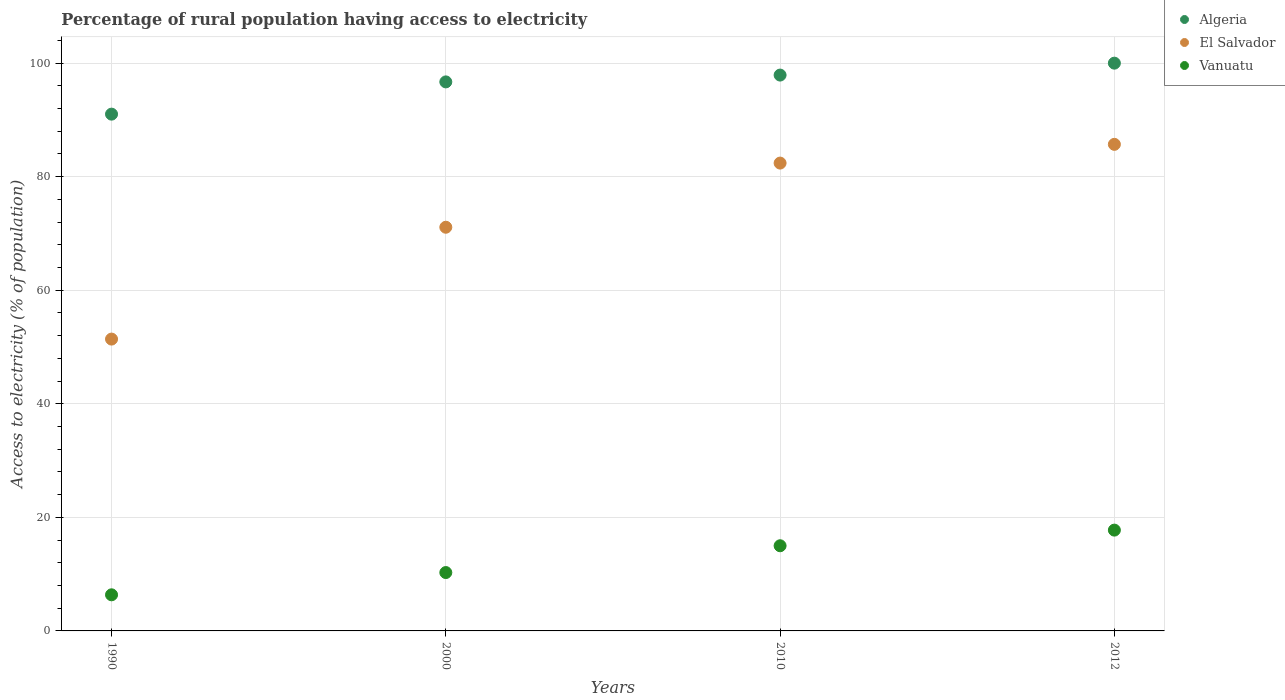How many different coloured dotlines are there?
Offer a terse response. 3. Is the number of dotlines equal to the number of legend labels?
Offer a terse response. Yes. What is the percentage of rural population having access to electricity in Vanuatu in 1990?
Your answer should be very brief. 6.36. Across all years, what is the maximum percentage of rural population having access to electricity in Vanuatu?
Provide a succinct answer. 17.75. Across all years, what is the minimum percentage of rural population having access to electricity in El Salvador?
Your response must be concise. 51.4. What is the total percentage of rural population having access to electricity in El Salvador in the graph?
Your response must be concise. 290.6. What is the difference between the percentage of rural population having access to electricity in El Salvador in 1990 and that in 2012?
Your response must be concise. -34.3. What is the difference between the percentage of rural population having access to electricity in El Salvador in 2000 and the percentage of rural population having access to electricity in Algeria in 2012?
Provide a short and direct response. -28.9. What is the average percentage of rural population having access to electricity in Vanuatu per year?
Provide a short and direct response. 12.35. In the year 2010, what is the difference between the percentage of rural population having access to electricity in El Salvador and percentage of rural population having access to electricity in Algeria?
Keep it short and to the point. -15.5. What is the ratio of the percentage of rural population having access to electricity in Vanuatu in 2000 to that in 2010?
Keep it short and to the point. 0.69. Is the percentage of rural population having access to electricity in Algeria in 1990 less than that in 2000?
Provide a succinct answer. Yes. Is the difference between the percentage of rural population having access to electricity in El Salvador in 2000 and 2012 greater than the difference between the percentage of rural population having access to electricity in Algeria in 2000 and 2012?
Make the answer very short. No. What is the difference between the highest and the second highest percentage of rural population having access to electricity in Vanuatu?
Ensure brevity in your answer.  2.75. What is the difference between the highest and the lowest percentage of rural population having access to electricity in Algeria?
Provide a succinct answer. 8.98. Does the percentage of rural population having access to electricity in Vanuatu monotonically increase over the years?
Offer a terse response. Yes. Is the percentage of rural population having access to electricity in Algeria strictly greater than the percentage of rural population having access to electricity in El Salvador over the years?
Make the answer very short. Yes. How many years are there in the graph?
Keep it short and to the point. 4. Are the values on the major ticks of Y-axis written in scientific E-notation?
Keep it short and to the point. No. Does the graph contain any zero values?
Provide a succinct answer. No. Does the graph contain grids?
Provide a short and direct response. Yes. How many legend labels are there?
Provide a short and direct response. 3. What is the title of the graph?
Make the answer very short. Percentage of rural population having access to electricity. What is the label or title of the Y-axis?
Offer a very short reply. Access to electricity (% of population). What is the Access to electricity (% of population) in Algeria in 1990?
Give a very brief answer. 91.02. What is the Access to electricity (% of population) in El Salvador in 1990?
Your response must be concise. 51.4. What is the Access to electricity (% of population) in Vanuatu in 1990?
Keep it short and to the point. 6.36. What is the Access to electricity (% of population) of Algeria in 2000?
Your answer should be compact. 96.7. What is the Access to electricity (% of population) in El Salvador in 2000?
Your response must be concise. 71.1. What is the Access to electricity (% of population) in Vanuatu in 2000?
Provide a short and direct response. 10.28. What is the Access to electricity (% of population) in Algeria in 2010?
Your answer should be compact. 97.9. What is the Access to electricity (% of population) of El Salvador in 2010?
Offer a very short reply. 82.4. What is the Access to electricity (% of population) in Algeria in 2012?
Your response must be concise. 100. What is the Access to electricity (% of population) of El Salvador in 2012?
Your answer should be compact. 85.7. What is the Access to electricity (% of population) of Vanuatu in 2012?
Your answer should be compact. 17.75. Across all years, what is the maximum Access to electricity (% of population) in El Salvador?
Ensure brevity in your answer.  85.7. Across all years, what is the maximum Access to electricity (% of population) of Vanuatu?
Make the answer very short. 17.75. Across all years, what is the minimum Access to electricity (% of population) in Algeria?
Your response must be concise. 91.02. Across all years, what is the minimum Access to electricity (% of population) in El Salvador?
Provide a short and direct response. 51.4. Across all years, what is the minimum Access to electricity (% of population) in Vanuatu?
Your answer should be compact. 6.36. What is the total Access to electricity (% of population) of Algeria in the graph?
Your response must be concise. 385.62. What is the total Access to electricity (% of population) in El Salvador in the graph?
Your answer should be very brief. 290.6. What is the total Access to electricity (% of population) in Vanuatu in the graph?
Make the answer very short. 49.4. What is the difference between the Access to electricity (% of population) in Algeria in 1990 and that in 2000?
Offer a terse response. -5.68. What is the difference between the Access to electricity (% of population) in El Salvador in 1990 and that in 2000?
Your response must be concise. -19.7. What is the difference between the Access to electricity (% of population) of Vanuatu in 1990 and that in 2000?
Give a very brief answer. -3.92. What is the difference between the Access to electricity (% of population) in Algeria in 1990 and that in 2010?
Offer a terse response. -6.88. What is the difference between the Access to electricity (% of population) of El Salvador in 1990 and that in 2010?
Your answer should be compact. -31. What is the difference between the Access to electricity (% of population) in Vanuatu in 1990 and that in 2010?
Offer a very short reply. -8.64. What is the difference between the Access to electricity (% of population) of Algeria in 1990 and that in 2012?
Give a very brief answer. -8.98. What is the difference between the Access to electricity (% of population) in El Salvador in 1990 and that in 2012?
Your response must be concise. -34.3. What is the difference between the Access to electricity (% of population) in Vanuatu in 1990 and that in 2012?
Provide a short and direct response. -11.39. What is the difference between the Access to electricity (% of population) of El Salvador in 2000 and that in 2010?
Your response must be concise. -11.3. What is the difference between the Access to electricity (% of population) in Vanuatu in 2000 and that in 2010?
Ensure brevity in your answer.  -4.72. What is the difference between the Access to electricity (% of population) of Algeria in 2000 and that in 2012?
Provide a succinct answer. -3.3. What is the difference between the Access to electricity (% of population) in El Salvador in 2000 and that in 2012?
Keep it short and to the point. -14.6. What is the difference between the Access to electricity (% of population) of Vanuatu in 2000 and that in 2012?
Your answer should be compact. -7.47. What is the difference between the Access to electricity (% of population) in Vanuatu in 2010 and that in 2012?
Your response must be concise. -2.75. What is the difference between the Access to electricity (% of population) in Algeria in 1990 and the Access to electricity (% of population) in El Salvador in 2000?
Your answer should be very brief. 19.92. What is the difference between the Access to electricity (% of population) of Algeria in 1990 and the Access to electricity (% of population) of Vanuatu in 2000?
Ensure brevity in your answer.  80.74. What is the difference between the Access to electricity (% of population) in El Salvador in 1990 and the Access to electricity (% of population) in Vanuatu in 2000?
Ensure brevity in your answer.  41.12. What is the difference between the Access to electricity (% of population) in Algeria in 1990 and the Access to electricity (% of population) in El Salvador in 2010?
Keep it short and to the point. 8.62. What is the difference between the Access to electricity (% of population) of Algeria in 1990 and the Access to electricity (% of population) of Vanuatu in 2010?
Give a very brief answer. 76.02. What is the difference between the Access to electricity (% of population) of El Salvador in 1990 and the Access to electricity (% of population) of Vanuatu in 2010?
Keep it short and to the point. 36.4. What is the difference between the Access to electricity (% of population) in Algeria in 1990 and the Access to electricity (% of population) in El Salvador in 2012?
Your answer should be compact. 5.32. What is the difference between the Access to electricity (% of population) of Algeria in 1990 and the Access to electricity (% of population) of Vanuatu in 2012?
Your answer should be very brief. 73.27. What is the difference between the Access to electricity (% of population) of El Salvador in 1990 and the Access to electricity (% of population) of Vanuatu in 2012?
Your response must be concise. 33.65. What is the difference between the Access to electricity (% of population) in Algeria in 2000 and the Access to electricity (% of population) in Vanuatu in 2010?
Offer a terse response. 81.7. What is the difference between the Access to electricity (% of population) in El Salvador in 2000 and the Access to electricity (% of population) in Vanuatu in 2010?
Offer a very short reply. 56.1. What is the difference between the Access to electricity (% of population) of Algeria in 2000 and the Access to electricity (% of population) of El Salvador in 2012?
Your response must be concise. 11. What is the difference between the Access to electricity (% of population) in Algeria in 2000 and the Access to electricity (% of population) in Vanuatu in 2012?
Ensure brevity in your answer.  78.95. What is the difference between the Access to electricity (% of population) in El Salvador in 2000 and the Access to electricity (% of population) in Vanuatu in 2012?
Provide a succinct answer. 53.35. What is the difference between the Access to electricity (% of population) in Algeria in 2010 and the Access to electricity (% of population) in El Salvador in 2012?
Give a very brief answer. 12.2. What is the difference between the Access to electricity (% of population) of Algeria in 2010 and the Access to electricity (% of population) of Vanuatu in 2012?
Provide a short and direct response. 80.15. What is the difference between the Access to electricity (% of population) in El Salvador in 2010 and the Access to electricity (% of population) in Vanuatu in 2012?
Your answer should be compact. 64.65. What is the average Access to electricity (% of population) of Algeria per year?
Give a very brief answer. 96.4. What is the average Access to electricity (% of population) in El Salvador per year?
Keep it short and to the point. 72.65. What is the average Access to electricity (% of population) in Vanuatu per year?
Offer a very short reply. 12.35. In the year 1990, what is the difference between the Access to electricity (% of population) of Algeria and Access to electricity (% of population) of El Salvador?
Your response must be concise. 39.62. In the year 1990, what is the difference between the Access to electricity (% of population) in Algeria and Access to electricity (% of population) in Vanuatu?
Make the answer very short. 84.66. In the year 1990, what is the difference between the Access to electricity (% of population) in El Salvador and Access to electricity (% of population) in Vanuatu?
Offer a very short reply. 45.04. In the year 2000, what is the difference between the Access to electricity (% of population) of Algeria and Access to electricity (% of population) of El Salvador?
Give a very brief answer. 25.6. In the year 2000, what is the difference between the Access to electricity (% of population) in Algeria and Access to electricity (% of population) in Vanuatu?
Your answer should be very brief. 86.42. In the year 2000, what is the difference between the Access to electricity (% of population) of El Salvador and Access to electricity (% of population) of Vanuatu?
Your response must be concise. 60.82. In the year 2010, what is the difference between the Access to electricity (% of population) in Algeria and Access to electricity (% of population) in El Salvador?
Keep it short and to the point. 15.5. In the year 2010, what is the difference between the Access to electricity (% of population) in Algeria and Access to electricity (% of population) in Vanuatu?
Keep it short and to the point. 82.9. In the year 2010, what is the difference between the Access to electricity (% of population) in El Salvador and Access to electricity (% of population) in Vanuatu?
Make the answer very short. 67.4. In the year 2012, what is the difference between the Access to electricity (% of population) of Algeria and Access to electricity (% of population) of El Salvador?
Offer a very short reply. 14.3. In the year 2012, what is the difference between the Access to electricity (% of population) in Algeria and Access to electricity (% of population) in Vanuatu?
Provide a succinct answer. 82.25. In the year 2012, what is the difference between the Access to electricity (% of population) of El Salvador and Access to electricity (% of population) of Vanuatu?
Your answer should be very brief. 67.95. What is the ratio of the Access to electricity (% of population) of Algeria in 1990 to that in 2000?
Offer a very short reply. 0.94. What is the ratio of the Access to electricity (% of population) of El Salvador in 1990 to that in 2000?
Offer a terse response. 0.72. What is the ratio of the Access to electricity (% of population) of Vanuatu in 1990 to that in 2000?
Your answer should be compact. 0.62. What is the ratio of the Access to electricity (% of population) of Algeria in 1990 to that in 2010?
Your response must be concise. 0.93. What is the ratio of the Access to electricity (% of population) in El Salvador in 1990 to that in 2010?
Keep it short and to the point. 0.62. What is the ratio of the Access to electricity (% of population) of Vanuatu in 1990 to that in 2010?
Offer a very short reply. 0.42. What is the ratio of the Access to electricity (% of population) in Algeria in 1990 to that in 2012?
Offer a terse response. 0.91. What is the ratio of the Access to electricity (% of population) in El Salvador in 1990 to that in 2012?
Ensure brevity in your answer.  0.6. What is the ratio of the Access to electricity (% of population) in Vanuatu in 1990 to that in 2012?
Offer a very short reply. 0.36. What is the ratio of the Access to electricity (% of population) of El Salvador in 2000 to that in 2010?
Make the answer very short. 0.86. What is the ratio of the Access to electricity (% of population) in Vanuatu in 2000 to that in 2010?
Make the answer very short. 0.69. What is the ratio of the Access to electricity (% of population) in Algeria in 2000 to that in 2012?
Ensure brevity in your answer.  0.97. What is the ratio of the Access to electricity (% of population) in El Salvador in 2000 to that in 2012?
Provide a succinct answer. 0.83. What is the ratio of the Access to electricity (% of population) in Vanuatu in 2000 to that in 2012?
Keep it short and to the point. 0.58. What is the ratio of the Access to electricity (% of population) in El Salvador in 2010 to that in 2012?
Provide a short and direct response. 0.96. What is the ratio of the Access to electricity (% of population) of Vanuatu in 2010 to that in 2012?
Your answer should be compact. 0.84. What is the difference between the highest and the second highest Access to electricity (% of population) in Algeria?
Give a very brief answer. 2.1. What is the difference between the highest and the second highest Access to electricity (% of population) in El Salvador?
Make the answer very short. 3.3. What is the difference between the highest and the second highest Access to electricity (% of population) in Vanuatu?
Keep it short and to the point. 2.75. What is the difference between the highest and the lowest Access to electricity (% of population) in Algeria?
Offer a terse response. 8.98. What is the difference between the highest and the lowest Access to electricity (% of population) of El Salvador?
Provide a succinct answer. 34.3. What is the difference between the highest and the lowest Access to electricity (% of population) of Vanuatu?
Your answer should be compact. 11.39. 